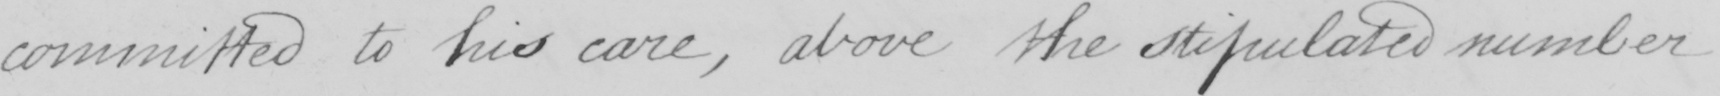What does this handwritten line say? committed to his care , above the stipulated number 